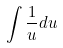<formula> <loc_0><loc_0><loc_500><loc_500>\int \frac { 1 } { u } d u</formula> 